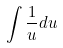<formula> <loc_0><loc_0><loc_500><loc_500>\int \frac { 1 } { u } d u</formula> 